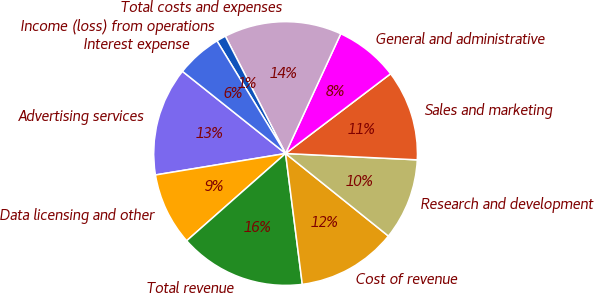<chart> <loc_0><loc_0><loc_500><loc_500><pie_chart><fcel>Advertising services<fcel>Data licensing and other<fcel>Total revenue<fcel>Cost of revenue<fcel>Research and development<fcel>Sales and marketing<fcel>General and administrative<fcel>Total costs and expenses<fcel>Income (loss) from operations<fcel>Interest expense<nl><fcel>13.31%<fcel>8.9%<fcel>15.52%<fcel>12.21%<fcel>10.0%<fcel>11.1%<fcel>7.79%<fcel>14.42%<fcel>1.16%<fcel>5.58%<nl></chart> 